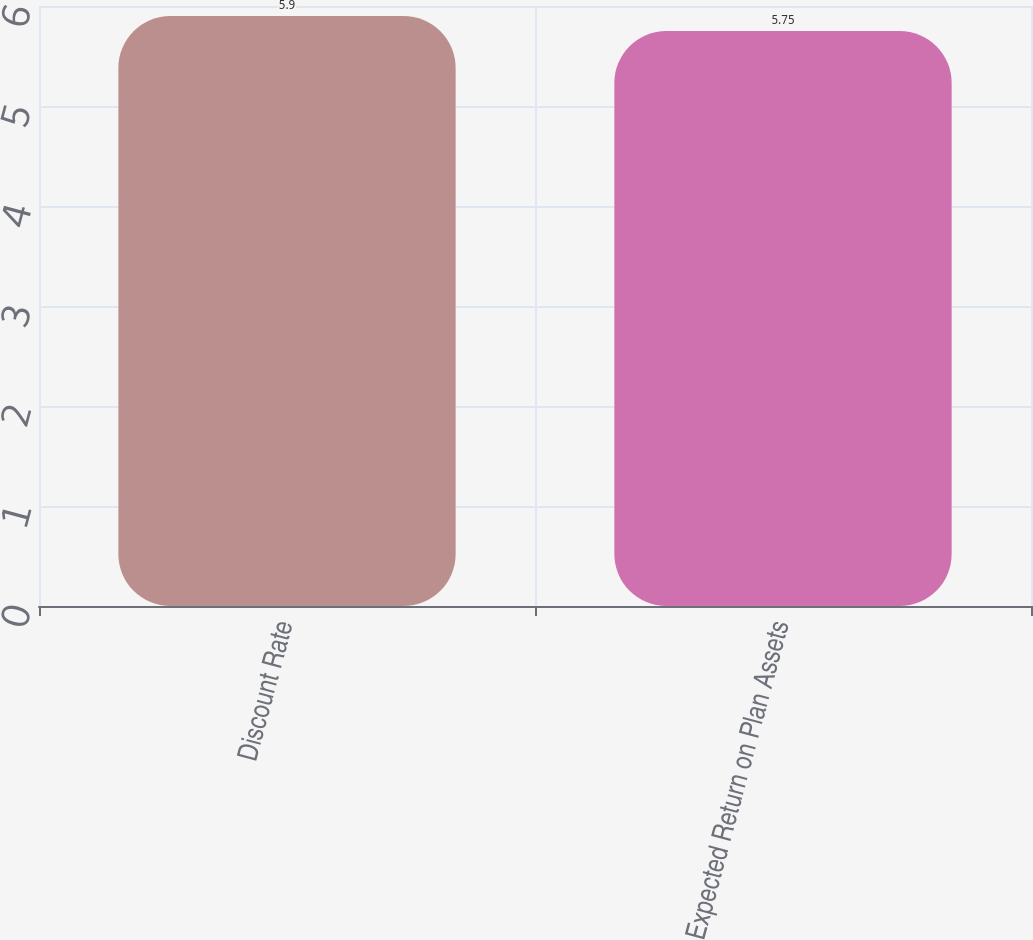<chart> <loc_0><loc_0><loc_500><loc_500><bar_chart><fcel>Discount Rate<fcel>Expected Return on Plan Assets<nl><fcel>5.9<fcel>5.75<nl></chart> 